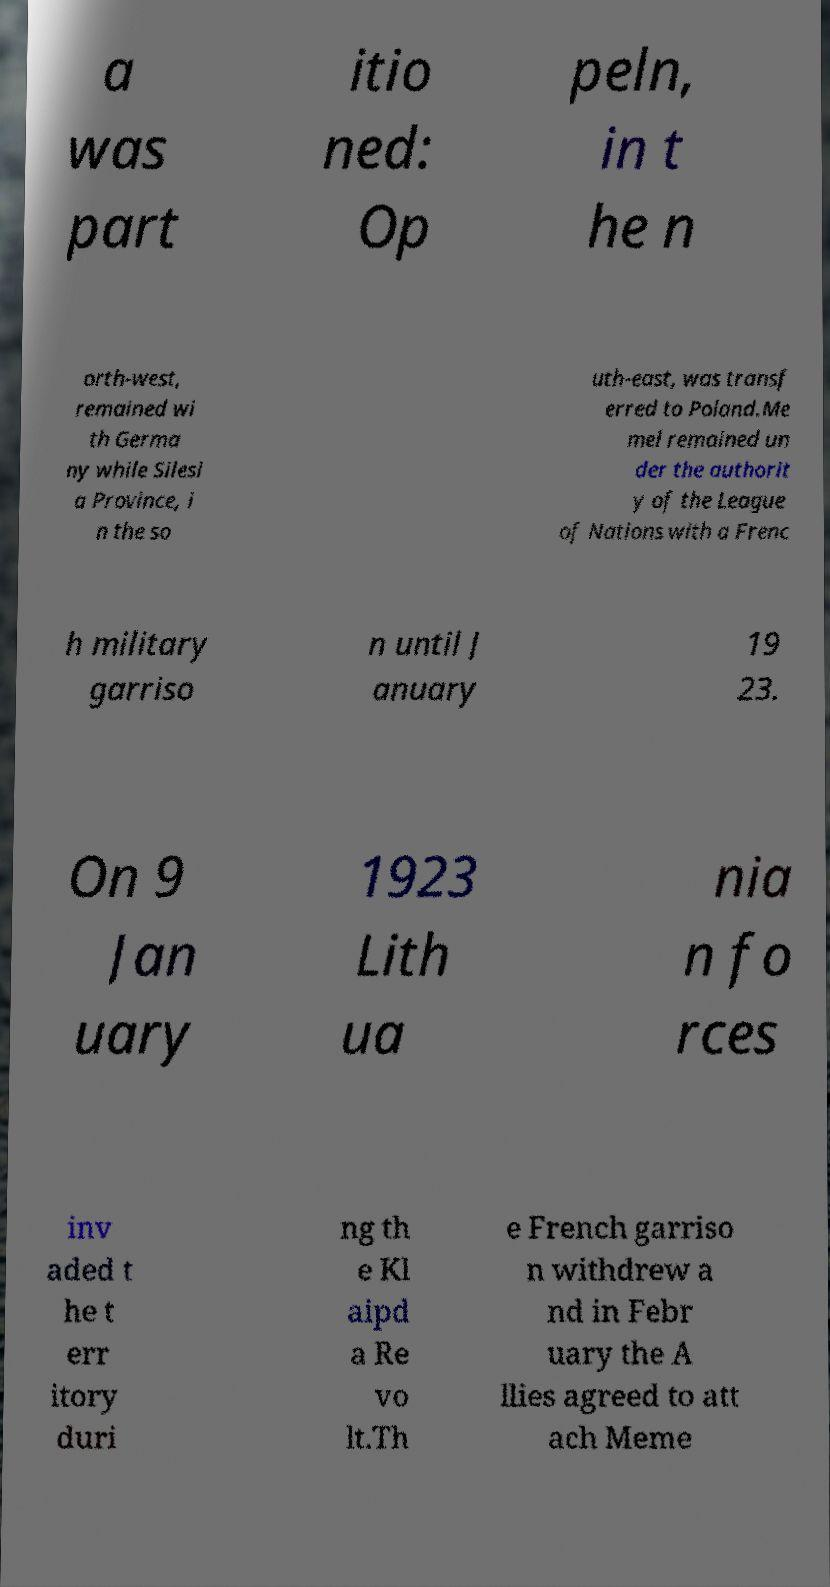Can you read and provide the text displayed in the image?This photo seems to have some interesting text. Can you extract and type it out for me? a was part itio ned: Op peln, in t he n orth-west, remained wi th Germa ny while Silesi a Province, i n the so uth-east, was transf erred to Poland.Me mel remained un der the authorit y of the League of Nations with a Frenc h military garriso n until J anuary 19 23. On 9 Jan uary 1923 Lith ua nia n fo rces inv aded t he t err itory duri ng th e Kl aipd a Re vo lt.Th e French garriso n withdrew a nd in Febr uary the A llies agreed to att ach Meme 